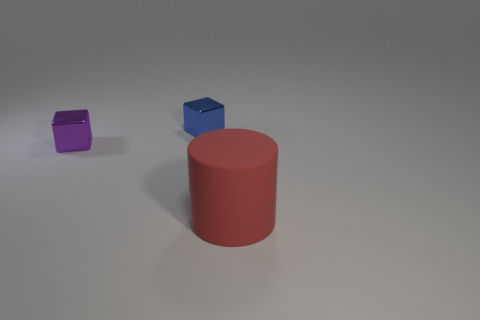Is there any other thing that has the same size as the rubber object?
Provide a succinct answer. No. What is the material of the blue block?
Offer a terse response. Metal. What size is the red cylinder that is in front of the cube that is on the right side of the metal object to the left of the tiny blue shiny object?
Your answer should be very brief. Large. How big is the red cylinder?
Offer a very short reply. Large. Is the size of the purple thing the same as the object right of the small blue metal thing?
Your answer should be compact. No. Is the size of the metallic cube that is on the right side of the purple block the same as the red matte cylinder?
Give a very brief answer. No. What color is the metal thing that is in front of the shiny object right of the tiny metallic thing in front of the blue shiny thing?
Ensure brevity in your answer.  Purple. Is the material of the tiny blue block the same as the tiny purple thing?
Your response must be concise. Yes. There is a thing that is both on the right side of the purple metal cube and in front of the small blue cube; how big is it?
Keep it short and to the point. Large. What number of blue things are the same size as the red cylinder?
Offer a terse response. 0. 